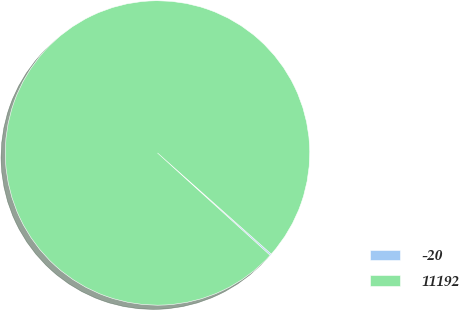Convert chart. <chart><loc_0><loc_0><loc_500><loc_500><pie_chart><fcel>-20<fcel>11192<nl><fcel>0.17%<fcel>99.83%<nl></chart> 